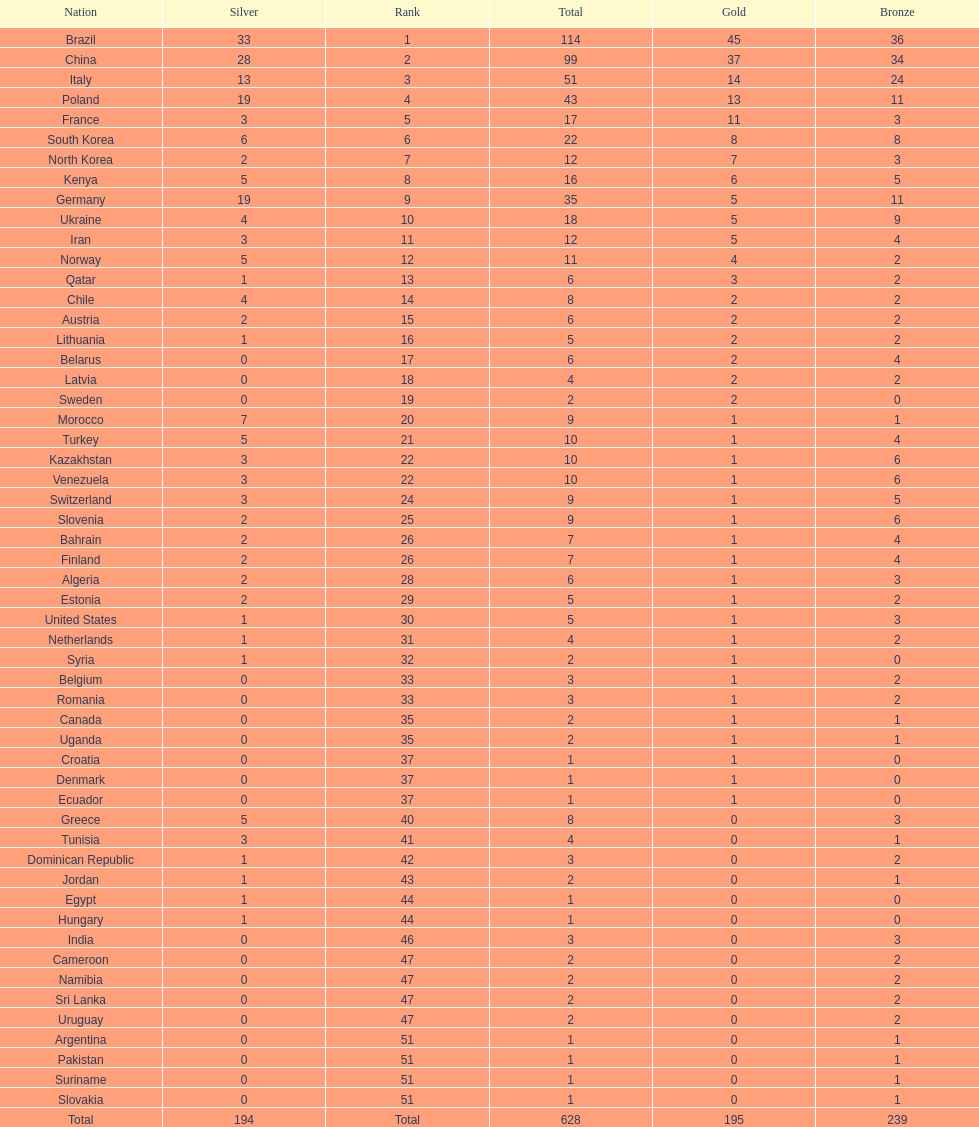Which nation earned the most gold medals? Brazil. 